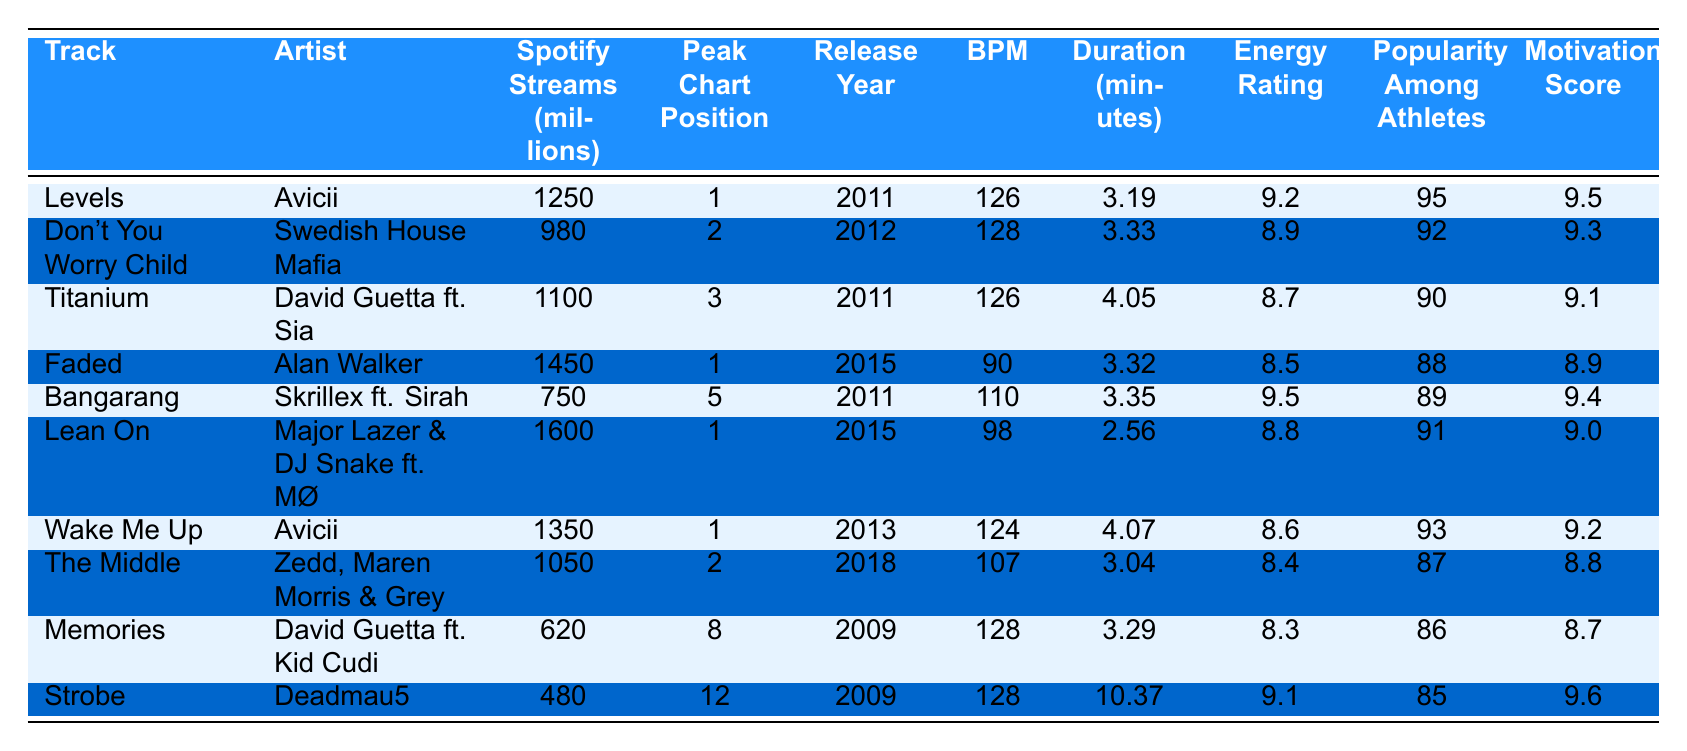What is the track with the highest Spotify streams? Looking at the table, "Faded" by Alan Walker has the highest number of Spotify streams at 1450 million.
Answer: Faded Which artist has the most tracks in the top 10? Avicii has two tracks in the top 10: "Levels" and "Wake Me Up".
Answer: Avicii What is the average BPM of the top 10 tracks? The BPM values are 126, 128, 126, 90, 110, 98, 124, 107, 128, and 128. Adding these gives 1285, and dividing by 10 tracks results in an average BPM of 128.5.
Answer: 128.5 Is "Titanium" by David Guetta less popular among athletes than "Strobe"? "Titanium" has a popularity rating of 90, while "Strobe" has a rating of 85, so "Titanium" is indeed more popular among athletes than "Strobe".
Answer: Yes Which track has the highest energy rating? By examining the energy ratings, "Bangarang" has the highest value at 9.5.
Answer: Bangarang What is the total number of Spotify streams for all tracks in the table? The total streams can be calculated by adding each track's streams: 1250 + 980 + 1100 + 1450 + 750 + 1600 + 1350 + 1050 + 620 + 480 = 10380 million streams.
Answer: 10380 million Was "Don't You Worry Child" released before or after 2015? The release year for "Don't You Worry Child" is 2012, which is before 2015.
Answer: Before What is the track with the lowest motivational score? "Memories" has the lowest motivational score at 8.7.
Answer: Memories Which track has both a high BPM and a high popularity rating? "Don't You Worry Child" has a BPM of 128 and a popularity rating of 92, which are both high values relative to others in the table.
Answer: Don't You Worry Child How many tracks have a peak chart position of 1? There are four tracks that reached a peak chart position of 1: "Levels," "Faded," "Lean On," and "Wake Me Up."
Answer: Four 